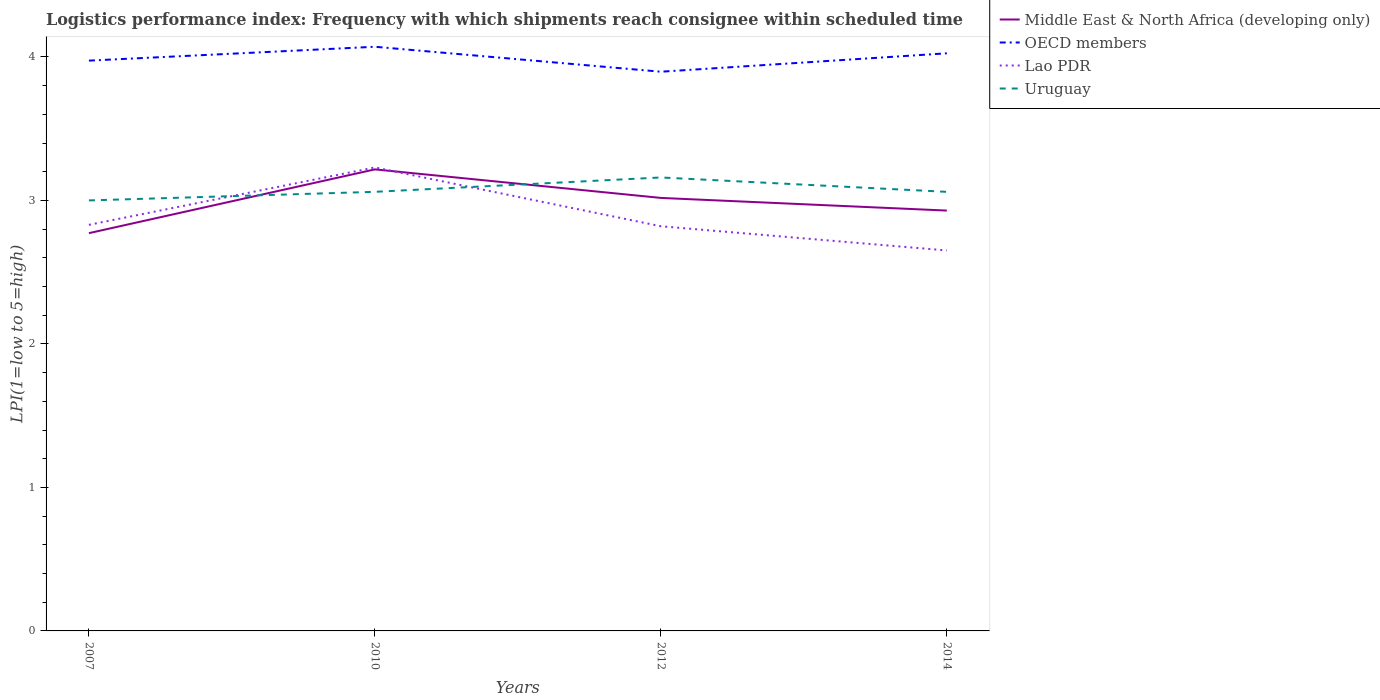How many different coloured lines are there?
Your answer should be compact. 4. Does the line corresponding to Lao PDR intersect with the line corresponding to OECD members?
Your answer should be compact. No. Across all years, what is the maximum logistics performance index in Lao PDR?
Ensure brevity in your answer.  2.65. What is the total logistics performance index in OECD members in the graph?
Your answer should be compact. -0.13. What is the difference between the highest and the second highest logistics performance index in Middle East & North Africa (developing only)?
Your answer should be very brief. 0.44. What is the difference between the highest and the lowest logistics performance index in Uruguay?
Ensure brevity in your answer.  1. Is the logistics performance index in Uruguay strictly greater than the logistics performance index in Lao PDR over the years?
Your response must be concise. No. Are the values on the major ticks of Y-axis written in scientific E-notation?
Give a very brief answer. No. Does the graph contain any zero values?
Offer a very short reply. No. Does the graph contain grids?
Make the answer very short. No. How are the legend labels stacked?
Provide a succinct answer. Vertical. What is the title of the graph?
Your response must be concise. Logistics performance index: Frequency with which shipments reach consignee within scheduled time. Does "Macao" appear as one of the legend labels in the graph?
Your answer should be very brief. No. What is the label or title of the Y-axis?
Provide a succinct answer. LPI(1=low to 5=high). What is the LPI(1=low to 5=high) in Middle East & North Africa (developing only) in 2007?
Offer a terse response. 2.77. What is the LPI(1=low to 5=high) in OECD members in 2007?
Offer a very short reply. 3.97. What is the LPI(1=low to 5=high) of Lao PDR in 2007?
Keep it short and to the point. 2.83. What is the LPI(1=low to 5=high) in Uruguay in 2007?
Ensure brevity in your answer.  3. What is the LPI(1=low to 5=high) in Middle East & North Africa (developing only) in 2010?
Offer a terse response. 3.22. What is the LPI(1=low to 5=high) of OECD members in 2010?
Provide a short and direct response. 4.07. What is the LPI(1=low to 5=high) in Lao PDR in 2010?
Make the answer very short. 3.23. What is the LPI(1=low to 5=high) of Uruguay in 2010?
Make the answer very short. 3.06. What is the LPI(1=low to 5=high) in Middle East & North Africa (developing only) in 2012?
Provide a short and direct response. 3.02. What is the LPI(1=low to 5=high) in OECD members in 2012?
Make the answer very short. 3.9. What is the LPI(1=low to 5=high) of Lao PDR in 2012?
Your response must be concise. 2.82. What is the LPI(1=low to 5=high) in Uruguay in 2012?
Your answer should be compact. 3.16. What is the LPI(1=low to 5=high) in Middle East & North Africa (developing only) in 2014?
Your response must be concise. 2.93. What is the LPI(1=low to 5=high) of OECD members in 2014?
Ensure brevity in your answer.  4.03. What is the LPI(1=low to 5=high) of Lao PDR in 2014?
Give a very brief answer. 2.65. What is the LPI(1=low to 5=high) in Uruguay in 2014?
Your answer should be very brief. 3.06. Across all years, what is the maximum LPI(1=low to 5=high) of Middle East & North Africa (developing only)?
Offer a terse response. 3.22. Across all years, what is the maximum LPI(1=low to 5=high) of OECD members?
Offer a very short reply. 4.07. Across all years, what is the maximum LPI(1=low to 5=high) in Lao PDR?
Offer a terse response. 3.23. Across all years, what is the maximum LPI(1=low to 5=high) of Uruguay?
Provide a succinct answer. 3.16. Across all years, what is the minimum LPI(1=low to 5=high) in Middle East & North Africa (developing only)?
Ensure brevity in your answer.  2.77. Across all years, what is the minimum LPI(1=low to 5=high) of OECD members?
Offer a very short reply. 3.9. Across all years, what is the minimum LPI(1=low to 5=high) in Lao PDR?
Ensure brevity in your answer.  2.65. What is the total LPI(1=low to 5=high) in Middle East & North Africa (developing only) in the graph?
Make the answer very short. 11.94. What is the total LPI(1=low to 5=high) of OECD members in the graph?
Provide a short and direct response. 15.97. What is the total LPI(1=low to 5=high) of Lao PDR in the graph?
Offer a very short reply. 11.53. What is the total LPI(1=low to 5=high) of Uruguay in the graph?
Make the answer very short. 12.28. What is the difference between the LPI(1=low to 5=high) in Middle East & North Africa (developing only) in 2007 and that in 2010?
Your answer should be very brief. -0.44. What is the difference between the LPI(1=low to 5=high) in OECD members in 2007 and that in 2010?
Make the answer very short. -0.1. What is the difference between the LPI(1=low to 5=high) in Uruguay in 2007 and that in 2010?
Offer a very short reply. -0.06. What is the difference between the LPI(1=low to 5=high) in Middle East & North Africa (developing only) in 2007 and that in 2012?
Make the answer very short. -0.25. What is the difference between the LPI(1=low to 5=high) of OECD members in 2007 and that in 2012?
Keep it short and to the point. 0.08. What is the difference between the LPI(1=low to 5=high) of Lao PDR in 2007 and that in 2012?
Ensure brevity in your answer.  0.01. What is the difference between the LPI(1=low to 5=high) of Uruguay in 2007 and that in 2012?
Your answer should be very brief. -0.16. What is the difference between the LPI(1=low to 5=high) of Middle East & North Africa (developing only) in 2007 and that in 2014?
Provide a succinct answer. -0.16. What is the difference between the LPI(1=low to 5=high) of OECD members in 2007 and that in 2014?
Make the answer very short. -0.05. What is the difference between the LPI(1=low to 5=high) in Lao PDR in 2007 and that in 2014?
Offer a very short reply. 0.18. What is the difference between the LPI(1=low to 5=high) in Uruguay in 2007 and that in 2014?
Provide a succinct answer. -0.06. What is the difference between the LPI(1=low to 5=high) of Middle East & North Africa (developing only) in 2010 and that in 2012?
Provide a succinct answer. 0.2. What is the difference between the LPI(1=low to 5=high) in OECD members in 2010 and that in 2012?
Give a very brief answer. 0.17. What is the difference between the LPI(1=low to 5=high) in Lao PDR in 2010 and that in 2012?
Provide a succinct answer. 0.41. What is the difference between the LPI(1=low to 5=high) of Middle East & North Africa (developing only) in 2010 and that in 2014?
Provide a succinct answer. 0.29. What is the difference between the LPI(1=low to 5=high) in OECD members in 2010 and that in 2014?
Provide a short and direct response. 0.05. What is the difference between the LPI(1=low to 5=high) of Lao PDR in 2010 and that in 2014?
Provide a succinct answer. 0.58. What is the difference between the LPI(1=low to 5=high) of Middle East & North Africa (developing only) in 2012 and that in 2014?
Provide a short and direct response. 0.09. What is the difference between the LPI(1=low to 5=high) in OECD members in 2012 and that in 2014?
Ensure brevity in your answer.  -0.13. What is the difference between the LPI(1=low to 5=high) in Lao PDR in 2012 and that in 2014?
Give a very brief answer. 0.17. What is the difference between the LPI(1=low to 5=high) of Uruguay in 2012 and that in 2014?
Your answer should be compact. 0.1. What is the difference between the LPI(1=low to 5=high) of Middle East & North Africa (developing only) in 2007 and the LPI(1=low to 5=high) of OECD members in 2010?
Your response must be concise. -1.3. What is the difference between the LPI(1=low to 5=high) of Middle East & North Africa (developing only) in 2007 and the LPI(1=low to 5=high) of Lao PDR in 2010?
Offer a terse response. -0.46. What is the difference between the LPI(1=low to 5=high) in Middle East & North Africa (developing only) in 2007 and the LPI(1=low to 5=high) in Uruguay in 2010?
Make the answer very short. -0.29. What is the difference between the LPI(1=low to 5=high) in OECD members in 2007 and the LPI(1=low to 5=high) in Lao PDR in 2010?
Your answer should be compact. 0.74. What is the difference between the LPI(1=low to 5=high) of OECD members in 2007 and the LPI(1=low to 5=high) of Uruguay in 2010?
Offer a very short reply. 0.91. What is the difference between the LPI(1=low to 5=high) of Lao PDR in 2007 and the LPI(1=low to 5=high) of Uruguay in 2010?
Your response must be concise. -0.23. What is the difference between the LPI(1=low to 5=high) in Middle East & North Africa (developing only) in 2007 and the LPI(1=low to 5=high) in OECD members in 2012?
Your answer should be compact. -1.12. What is the difference between the LPI(1=low to 5=high) in Middle East & North Africa (developing only) in 2007 and the LPI(1=low to 5=high) in Lao PDR in 2012?
Keep it short and to the point. -0.05. What is the difference between the LPI(1=low to 5=high) of Middle East & North Africa (developing only) in 2007 and the LPI(1=low to 5=high) of Uruguay in 2012?
Give a very brief answer. -0.39. What is the difference between the LPI(1=low to 5=high) of OECD members in 2007 and the LPI(1=low to 5=high) of Lao PDR in 2012?
Ensure brevity in your answer.  1.15. What is the difference between the LPI(1=low to 5=high) in OECD members in 2007 and the LPI(1=low to 5=high) in Uruguay in 2012?
Your answer should be compact. 0.81. What is the difference between the LPI(1=low to 5=high) of Lao PDR in 2007 and the LPI(1=low to 5=high) of Uruguay in 2012?
Provide a succinct answer. -0.33. What is the difference between the LPI(1=low to 5=high) in Middle East & North Africa (developing only) in 2007 and the LPI(1=low to 5=high) in OECD members in 2014?
Offer a terse response. -1.25. What is the difference between the LPI(1=low to 5=high) of Middle East & North Africa (developing only) in 2007 and the LPI(1=low to 5=high) of Lao PDR in 2014?
Offer a terse response. 0.12. What is the difference between the LPI(1=low to 5=high) of Middle East & North Africa (developing only) in 2007 and the LPI(1=low to 5=high) of Uruguay in 2014?
Offer a terse response. -0.29. What is the difference between the LPI(1=low to 5=high) of OECD members in 2007 and the LPI(1=low to 5=high) of Lao PDR in 2014?
Your answer should be compact. 1.32. What is the difference between the LPI(1=low to 5=high) in OECD members in 2007 and the LPI(1=low to 5=high) in Uruguay in 2014?
Provide a succinct answer. 0.91. What is the difference between the LPI(1=low to 5=high) of Lao PDR in 2007 and the LPI(1=low to 5=high) of Uruguay in 2014?
Give a very brief answer. -0.23. What is the difference between the LPI(1=low to 5=high) in Middle East & North Africa (developing only) in 2010 and the LPI(1=low to 5=high) in OECD members in 2012?
Offer a terse response. -0.68. What is the difference between the LPI(1=low to 5=high) in Middle East & North Africa (developing only) in 2010 and the LPI(1=low to 5=high) in Lao PDR in 2012?
Your answer should be very brief. 0.4. What is the difference between the LPI(1=low to 5=high) in Middle East & North Africa (developing only) in 2010 and the LPI(1=low to 5=high) in Uruguay in 2012?
Keep it short and to the point. 0.06. What is the difference between the LPI(1=low to 5=high) of OECD members in 2010 and the LPI(1=low to 5=high) of Lao PDR in 2012?
Your response must be concise. 1.25. What is the difference between the LPI(1=low to 5=high) of OECD members in 2010 and the LPI(1=low to 5=high) of Uruguay in 2012?
Provide a short and direct response. 0.91. What is the difference between the LPI(1=low to 5=high) in Lao PDR in 2010 and the LPI(1=low to 5=high) in Uruguay in 2012?
Ensure brevity in your answer.  0.07. What is the difference between the LPI(1=low to 5=high) of Middle East & North Africa (developing only) in 2010 and the LPI(1=low to 5=high) of OECD members in 2014?
Offer a terse response. -0.81. What is the difference between the LPI(1=low to 5=high) in Middle East & North Africa (developing only) in 2010 and the LPI(1=low to 5=high) in Lao PDR in 2014?
Give a very brief answer. 0.56. What is the difference between the LPI(1=low to 5=high) in Middle East & North Africa (developing only) in 2010 and the LPI(1=low to 5=high) in Uruguay in 2014?
Your response must be concise. 0.16. What is the difference between the LPI(1=low to 5=high) of OECD members in 2010 and the LPI(1=low to 5=high) of Lao PDR in 2014?
Keep it short and to the point. 1.42. What is the difference between the LPI(1=low to 5=high) in OECD members in 2010 and the LPI(1=low to 5=high) in Uruguay in 2014?
Your answer should be very brief. 1.01. What is the difference between the LPI(1=low to 5=high) in Lao PDR in 2010 and the LPI(1=low to 5=high) in Uruguay in 2014?
Keep it short and to the point. 0.17. What is the difference between the LPI(1=low to 5=high) in Middle East & North Africa (developing only) in 2012 and the LPI(1=low to 5=high) in OECD members in 2014?
Offer a very short reply. -1.01. What is the difference between the LPI(1=low to 5=high) in Middle East & North Africa (developing only) in 2012 and the LPI(1=low to 5=high) in Lao PDR in 2014?
Provide a short and direct response. 0.37. What is the difference between the LPI(1=low to 5=high) in Middle East & North Africa (developing only) in 2012 and the LPI(1=low to 5=high) in Uruguay in 2014?
Give a very brief answer. -0.04. What is the difference between the LPI(1=low to 5=high) of OECD members in 2012 and the LPI(1=low to 5=high) of Lao PDR in 2014?
Make the answer very short. 1.25. What is the difference between the LPI(1=low to 5=high) in OECD members in 2012 and the LPI(1=low to 5=high) in Uruguay in 2014?
Offer a terse response. 0.84. What is the difference between the LPI(1=low to 5=high) of Lao PDR in 2012 and the LPI(1=low to 5=high) of Uruguay in 2014?
Your answer should be compact. -0.24. What is the average LPI(1=low to 5=high) of Middle East & North Africa (developing only) per year?
Ensure brevity in your answer.  2.98. What is the average LPI(1=low to 5=high) of OECD members per year?
Give a very brief answer. 3.99. What is the average LPI(1=low to 5=high) of Lao PDR per year?
Your answer should be compact. 2.88. What is the average LPI(1=low to 5=high) of Uruguay per year?
Give a very brief answer. 3.07. In the year 2007, what is the difference between the LPI(1=low to 5=high) in Middle East & North Africa (developing only) and LPI(1=low to 5=high) in OECD members?
Make the answer very short. -1.2. In the year 2007, what is the difference between the LPI(1=low to 5=high) of Middle East & North Africa (developing only) and LPI(1=low to 5=high) of Lao PDR?
Make the answer very short. -0.06. In the year 2007, what is the difference between the LPI(1=low to 5=high) in Middle East & North Africa (developing only) and LPI(1=low to 5=high) in Uruguay?
Provide a short and direct response. -0.23. In the year 2007, what is the difference between the LPI(1=low to 5=high) of OECD members and LPI(1=low to 5=high) of Lao PDR?
Offer a terse response. 1.14. In the year 2007, what is the difference between the LPI(1=low to 5=high) in OECD members and LPI(1=low to 5=high) in Uruguay?
Your response must be concise. 0.97. In the year 2007, what is the difference between the LPI(1=low to 5=high) of Lao PDR and LPI(1=low to 5=high) of Uruguay?
Offer a terse response. -0.17. In the year 2010, what is the difference between the LPI(1=low to 5=high) of Middle East & North Africa (developing only) and LPI(1=low to 5=high) of OECD members?
Your response must be concise. -0.85. In the year 2010, what is the difference between the LPI(1=low to 5=high) in Middle East & North Africa (developing only) and LPI(1=low to 5=high) in Lao PDR?
Your answer should be compact. -0.01. In the year 2010, what is the difference between the LPI(1=low to 5=high) in Middle East & North Africa (developing only) and LPI(1=low to 5=high) in Uruguay?
Offer a terse response. 0.16. In the year 2010, what is the difference between the LPI(1=low to 5=high) of OECD members and LPI(1=low to 5=high) of Lao PDR?
Keep it short and to the point. 0.84. In the year 2010, what is the difference between the LPI(1=low to 5=high) in OECD members and LPI(1=low to 5=high) in Uruguay?
Your response must be concise. 1.01. In the year 2010, what is the difference between the LPI(1=low to 5=high) in Lao PDR and LPI(1=low to 5=high) in Uruguay?
Give a very brief answer. 0.17. In the year 2012, what is the difference between the LPI(1=low to 5=high) in Middle East & North Africa (developing only) and LPI(1=low to 5=high) in OECD members?
Provide a short and direct response. -0.88. In the year 2012, what is the difference between the LPI(1=low to 5=high) in Middle East & North Africa (developing only) and LPI(1=low to 5=high) in Lao PDR?
Offer a terse response. 0.2. In the year 2012, what is the difference between the LPI(1=low to 5=high) of Middle East & North Africa (developing only) and LPI(1=low to 5=high) of Uruguay?
Provide a short and direct response. -0.14. In the year 2012, what is the difference between the LPI(1=low to 5=high) in OECD members and LPI(1=low to 5=high) in Lao PDR?
Make the answer very short. 1.08. In the year 2012, what is the difference between the LPI(1=low to 5=high) in OECD members and LPI(1=low to 5=high) in Uruguay?
Provide a short and direct response. 0.74. In the year 2012, what is the difference between the LPI(1=low to 5=high) of Lao PDR and LPI(1=low to 5=high) of Uruguay?
Your response must be concise. -0.34. In the year 2014, what is the difference between the LPI(1=low to 5=high) in Middle East & North Africa (developing only) and LPI(1=low to 5=high) in OECD members?
Provide a short and direct response. -1.1. In the year 2014, what is the difference between the LPI(1=low to 5=high) in Middle East & North Africa (developing only) and LPI(1=low to 5=high) in Lao PDR?
Your response must be concise. 0.28. In the year 2014, what is the difference between the LPI(1=low to 5=high) of Middle East & North Africa (developing only) and LPI(1=low to 5=high) of Uruguay?
Your answer should be compact. -0.13. In the year 2014, what is the difference between the LPI(1=low to 5=high) of OECD members and LPI(1=low to 5=high) of Lao PDR?
Your answer should be compact. 1.37. In the year 2014, what is the difference between the LPI(1=low to 5=high) in OECD members and LPI(1=low to 5=high) in Uruguay?
Offer a very short reply. 0.97. In the year 2014, what is the difference between the LPI(1=low to 5=high) of Lao PDR and LPI(1=low to 5=high) of Uruguay?
Offer a very short reply. -0.41. What is the ratio of the LPI(1=low to 5=high) in Middle East & North Africa (developing only) in 2007 to that in 2010?
Your answer should be compact. 0.86. What is the ratio of the LPI(1=low to 5=high) of OECD members in 2007 to that in 2010?
Offer a very short reply. 0.98. What is the ratio of the LPI(1=low to 5=high) in Lao PDR in 2007 to that in 2010?
Make the answer very short. 0.88. What is the ratio of the LPI(1=low to 5=high) of Uruguay in 2007 to that in 2010?
Your response must be concise. 0.98. What is the ratio of the LPI(1=low to 5=high) in Middle East & North Africa (developing only) in 2007 to that in 2012?
Keep it short and to the point. 0.92. What is the ratio of the LPI(1=low to 5=high) of OECD members in 2007 to that in 2012?
Make the answer very short. 1.02. What is the ratio of the LPI(1=low to 5=high) in Uruguay in 2007 to that in 2012?
Give a very brief answer. 0.95. What is the ratio of the LPI(1=low to 5=high) in Middle East & North Africa (developing only) in 2007 to that in 2014?
Your response must be concise. 0.95. What is the ratio of the LPI(1=low to 5=high) of OECD members in 2007 to that in 2014?
Offer a very short reply. 0.99. What is the ratio of the LPI(1=low to 5=high) of Lao PDR in 2007 to that in 2014?
Provide a succinct answer. 1.07. What is the ratio of the LPI(1=low to 5=high) in Uruguay in 2007 to that in 2014?
Provide a succinct answer. 0.98. What is the ratio of the LPI(1=low to 5=high) of Middle East & North Africa (developing only) in 2010 to that in 2012?
Offer a terse response. 1.07. What is the ratio of the LPI(1=low to 5=high) of OECD members in 2010 to that in 2012?
Ensure brevity in your answer.  1.04. What is the ratio of the LPI(1=low to 5=high) in Lao PDR in 2010 to that in 2012?
Provide a succinct answer. 1.15. What is the ratio of the LPI(1=low to 5=high) in Uruguay in 2010 to that in 2012?
Your answer should be compact. 0.97. What is the ratio of the LPI(1=low to 5=high) of Middle East & North Africa (developing only) in 2010 to that in 2014?
Offer a terse response. 1.1. What is the ratio of the LPI(1=low to 5=high) of OECD members in 2010 to that in 2014?
Provide a short and direct response. 1.01. What is the ratio of the LPI(1=low to 5=high) of Lao PDR in 2010 to that in 2014?
Give a very brief answer. 1.22. What is the ratio of the LPI(1=low to 5=high) in Uruguay in 2010 to that in 2014?
Make the answer very short. 1. What is the ratio of the LPI(1=low to 5=high) of Middle East & North Africa (developing only) in 2012 to that in 2014?
Give a very brief answer. 1.03. What is the ratio of the LPI(1=low to 5=high) in OECD members in 2012 to that in 2014?
Offer a very short reply. 0.97. What is the ratio of the LPI(1=low to 5=high) in Lao PDR in 2012 to that in 2014?
Make the answer very short. 1.06. What is the ratio of the LPI(1=low to 5=high) in Uruguay in 2012 to that in 2014?
Ensure brevity in your answer.  1.03. What is the difference between the highest and the second highest LPI(1=low to 5=high) of Middle East & North Africa (developing only)?
Your answer should be compact. 0.2. What is the difference between the highest and the second highest LPI(1=low to 5=high) in OECD members?
Your answer should be compact. 0.05. What is the difference between the highest and the second highest LPI(1=low to 5=high) in Lao PDR?
Give a very brief answer. 0.4. What is the difference between the highest and the second highest LPI(1=low to 5=high) of Uruguay?
Offer a very short reply. 0.1. What is the difference between the highest and the lowest LPI(1=low to 5=high) in Middle East & North Africa (developing only)?
Provide a short and direct response. 0.44. What is the difference between the highest and the lowest LPI(1=low to 5=high) of OECD members?
Your answer should be compact. 0.17. What is the difference between the highest and the lowest LPI(1=low to 5=high) in Lao PDR?
Make the answer very short. 0.58. What is the difference between the highest and the lowest LPI(1=low to 5=high) in Uruguay?
Provide a succinct answer. 0.16. 